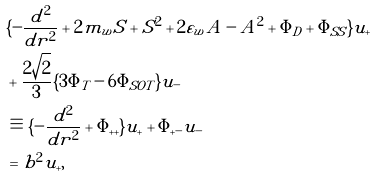Convert formula to latex. <formula><loc_0><loc_0><loc_500><loc_500>& \{ - \frac { d ^ { 2 } } { d r ^ { 2 } } + 2 m _ { w } S + S ^ { 2 } + 2 \varepsilon _ { w } A - A ^ { 2 } + \Phi _ { D } + \Phi _ { S S } \} u _ { + } \\ & + \frac { 2 \sqrt { 2 } } { 3 } \{ 3 \Phi _ { T } - 6 \Phi _ { S O T } \} u _ { - } \\ & \equiv \{ - \frac { d ^ { 2 } } { d r ^ { 2 } } + \Phi _ { + + } \} u _ { + } + \Phi _ { + - } u _ { - } \\ & = b ^ { 2 } u _ { + } ,</formula> 